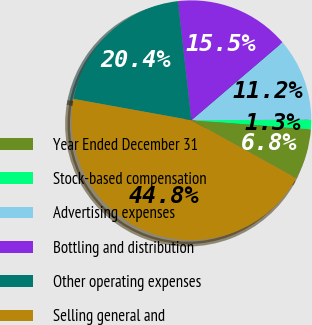Convert chart to OTSL. <chart><loc_0><loc_0><loc_500><loc_500><pie_chart><fcel>Year Ended December 31<fcel>Stock-based compensation<fcel>Advertising expenses<fcel>Bottling and distribution<fcel>Other operating expenses<fcel>Selling general and<nl><fcel>6.83%<fcel>1.29%<fcel>11.18%<fcel>15.53%<fcel>20.36%<fcel>44.81%<nl></chart> 